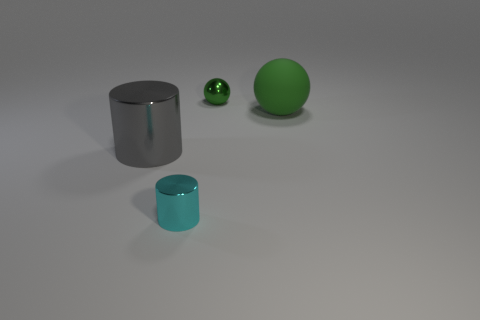Subtract all cyan cylinders. How many cylinders are left? 1 Subtract 2 balls. How many balls are left? 0 Subtract all gray cubes. How many cyan spheres are left? 0 Subtract all green metal blocks. Subtract all matte spheres. How many objects are left? 3 Add 1 gray shiny objects. How many gray shiny objects are left? 2 Add 3 rubber things. How many rubber things exist? 4 Add 4 tiny brown metallic cylinders. How many objects exist? 8 Subtract 1 cyan cylinders. How many objects are left? 3 Subtract all red cylinders. Subtract all blue blocks. How many cylinders are left? 2 